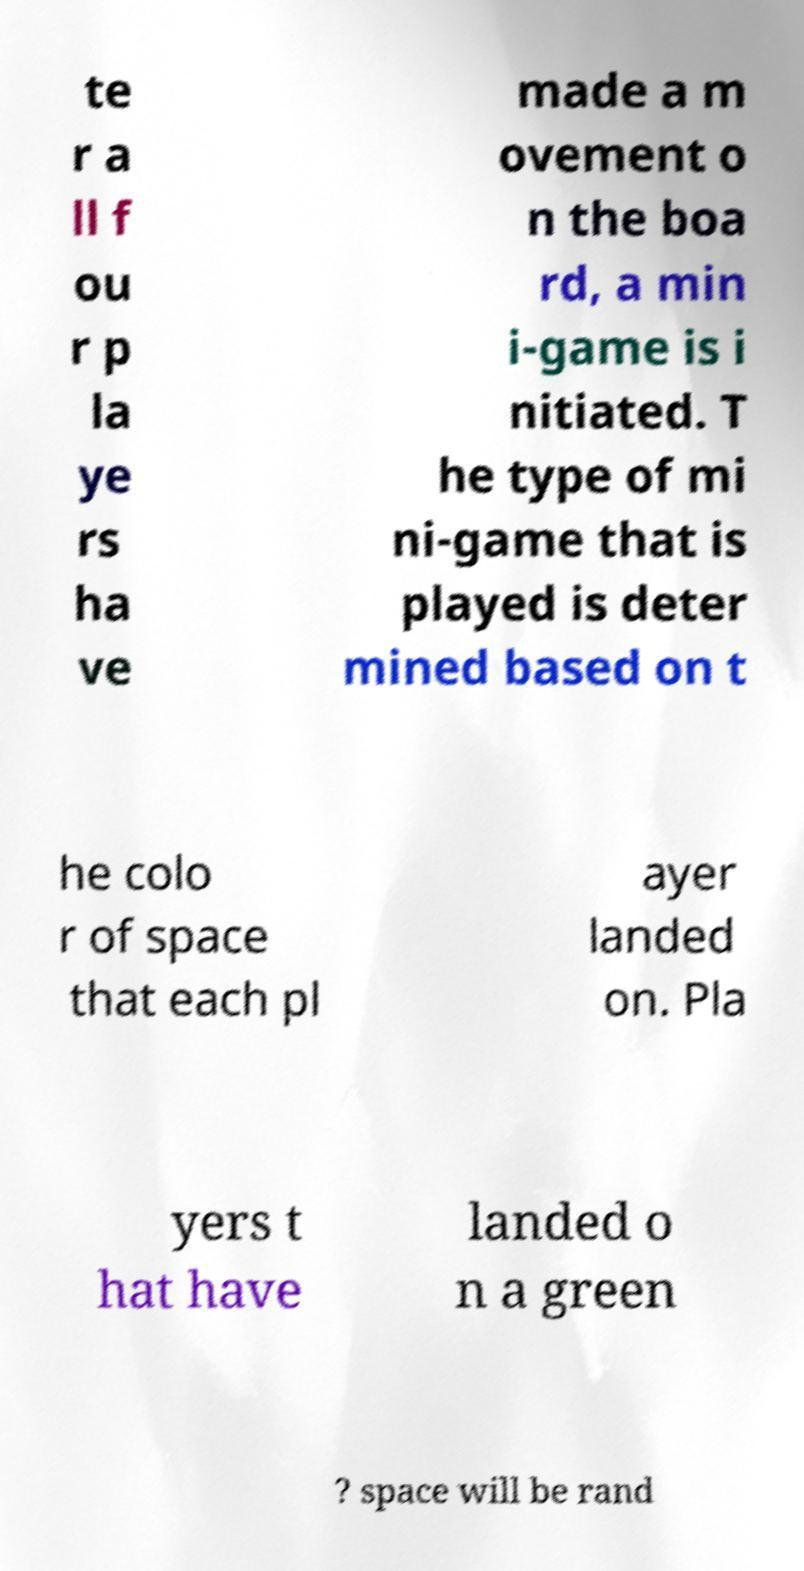Please identify and transcribe the text found in this image. te r a ll f ou r p la ye rs ha ve made a m ovement o n the boa rd, a min i-game is i nitiated. T he type of mi ni-game that is played is deter mined based on t he colo r of space that each pl ayer landed on. Pla yers t hat have landed o n a green ? space will be rand 